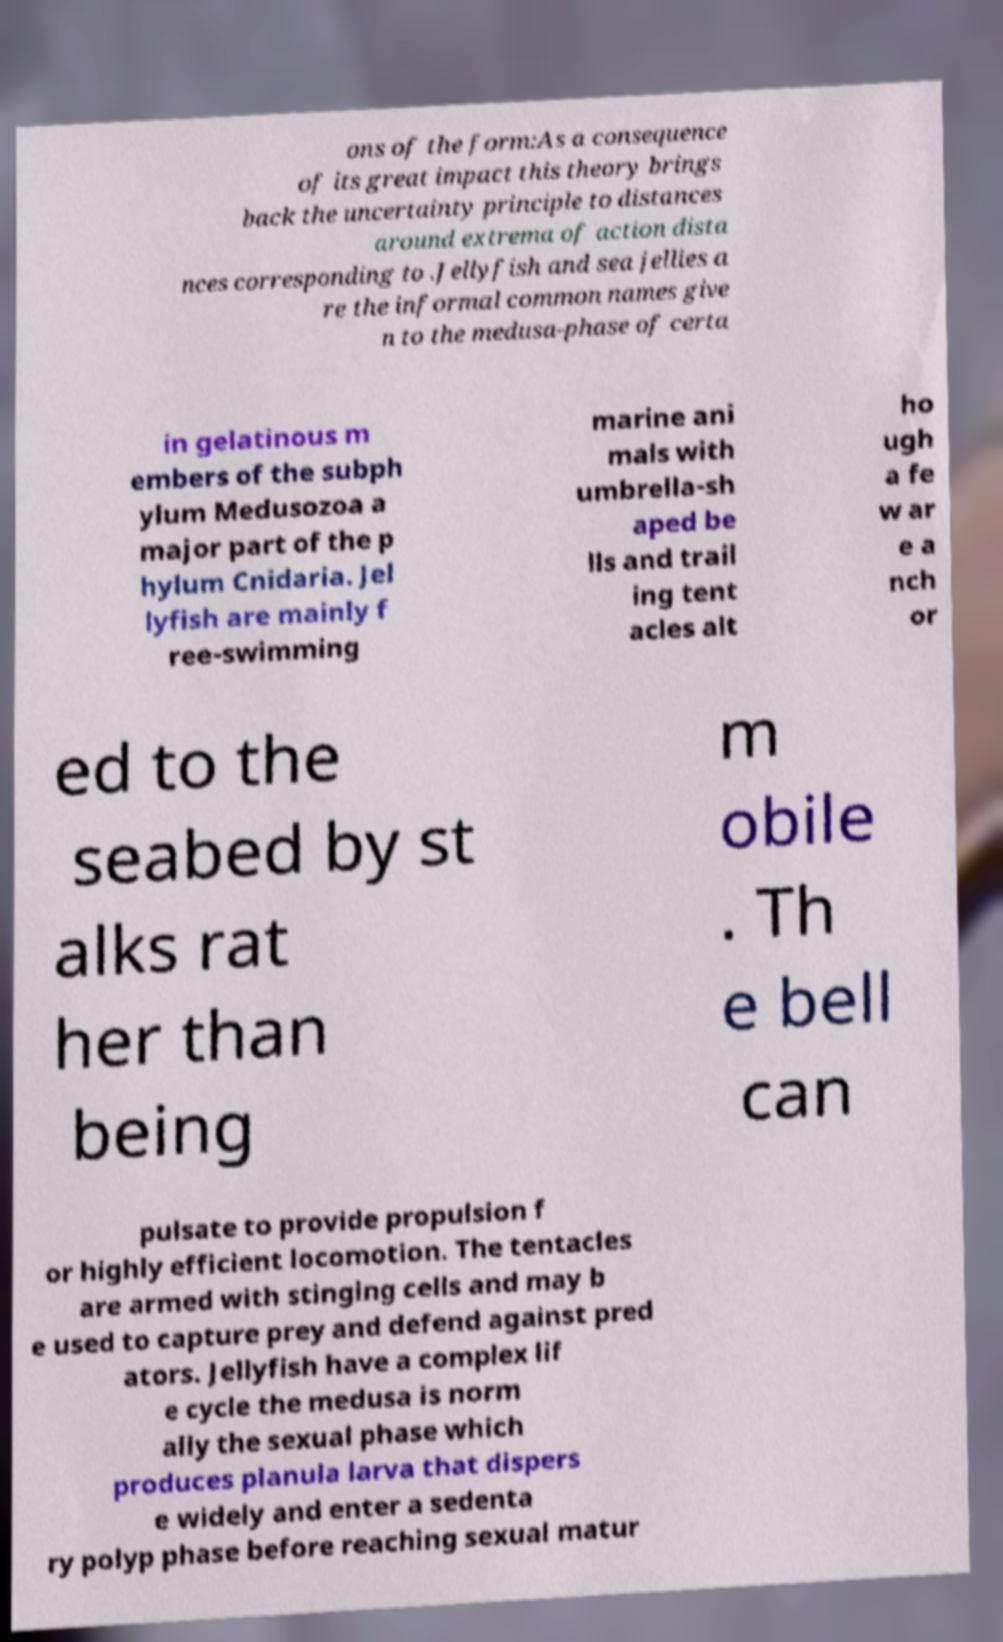Can you read and provide the text displayed in the image?This photo seems to have some interesting text. Can you extract and type it out for me? ons of the form:As a consequence of its great impact this theory brings back the uncertainty principle to distances around extrema of action dista nces corresponding to .Jellyfish and sea jellies a re the informal common names give n to the medusa-phase of certa in gelatinous m embers of the subph ylum Medusozoa a major part of the p hylum Cnidaria. Jel lyfish are mainly f ree-swimming marine ani mals with umbrella-sh aped be lls and trail ing tent acles alt ho ugh a fe w ar e a nch or ed to the seabed by st alks rat her than being m obile . Th e bell can pulsate to provide propulsion f or highly efficient locomotion. The tentacles are armed with stinging cells and may b e used to capture prey and defend against pred ators. Jellyfish have a complex lif e cycle the medusa is norm ally the sexual phase which produces planula larva that dispers e widely and enter a sedenta ry polyp phase before reaching sexual matur 